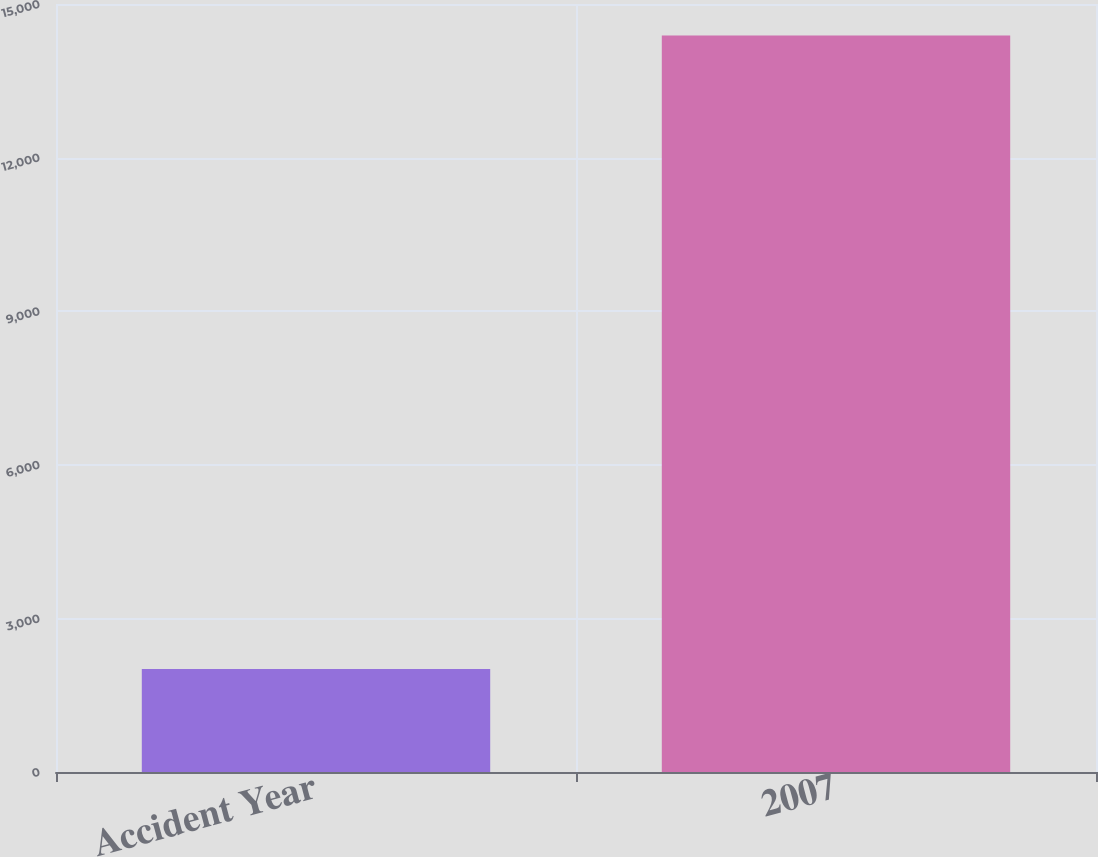Convert chart to OTSL. <chart><loc_0><loc_0><loc_500><loc_500><bar_chart><fcel>Accident Year<fcel>2007<nl><fcel>2012<fcel>14383<nl></chart> 